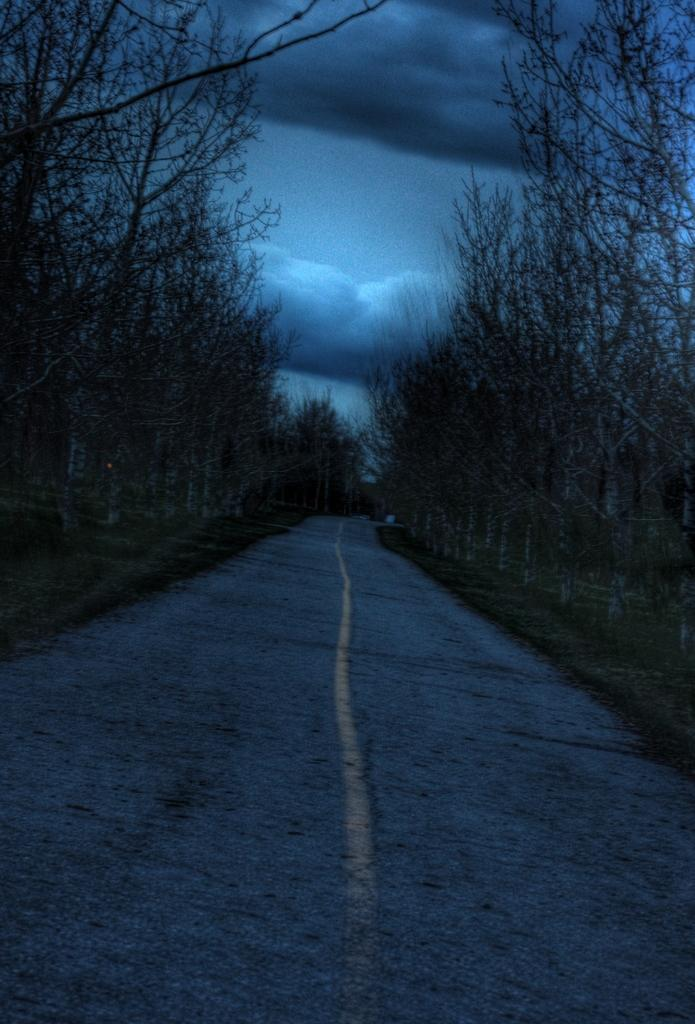What type of vegetation can be seen in the image? There are trees in the image. What is visible at the top of the image? The sky is visible at the top of the image. What can be observed in the sky? Clouds are present in the sky. How would you describe the overall lighting in the image? The image appears to be slightly dark. How many ladybugs can be seen crawling on the trees in the image? There are no ladybugs visible in the image; it only features trees and clouds in the sky. What type of curve is present in the image? There is no curve visible in the image; it primarily consists of trees, sky, and clouds. 